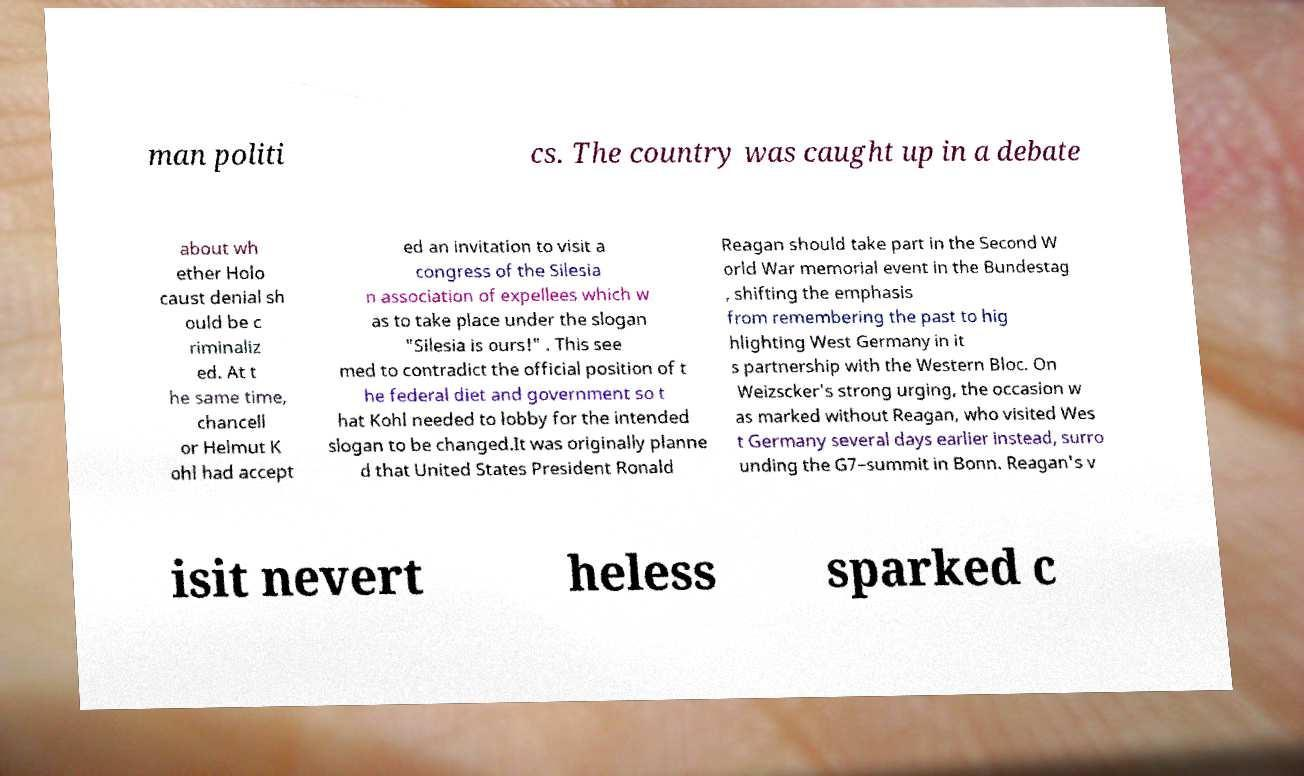Can you read and provide the text displayed in the image?This photo seems to have some interesting text. Can you extract and type it out for me? man politi cs. The country was caught up in a debate about wh ether Holo caust denial sh ould be c riminaliz ed. At t he same time, chancell or Helmut K ohl had accept ed an invitation to visit a congress of the Silesia n association of expellees which w as to take place under the slogan "Silesia is ours!" . This see med to contradict the official position of t he federal diet and government so t hat Kohl needed to lobby for the intended slogan to be changed.It was originally planne d that United States President Ronald Reagan should take part in the Second W orld War memorial event in the Bundestag , shifting the emphasis from remembering the past to hig hlighting West Germany in it s partnership with the Western Bloc. On Weizscker's strong urging, the occasion w as marked without Reagan, who visited Wes t Germany several days earlier instead, surro unding the G7–summit in Bonn. Reagan's v isit nevert heless sparked c 